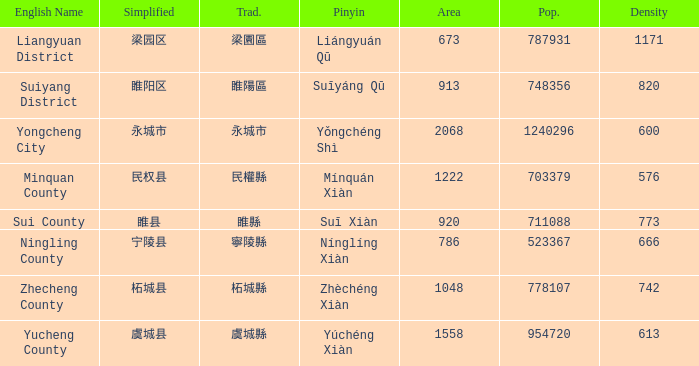What is the Pinyin for the simplified 虞城县? Yúchéng Xiàn. 